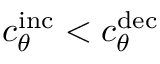<formula> <loc_0><loc_0><loc_500><loc_500>c _ { \theta } ^ { i n c } < c _ { \theta } ^ { d e c }</formula> 